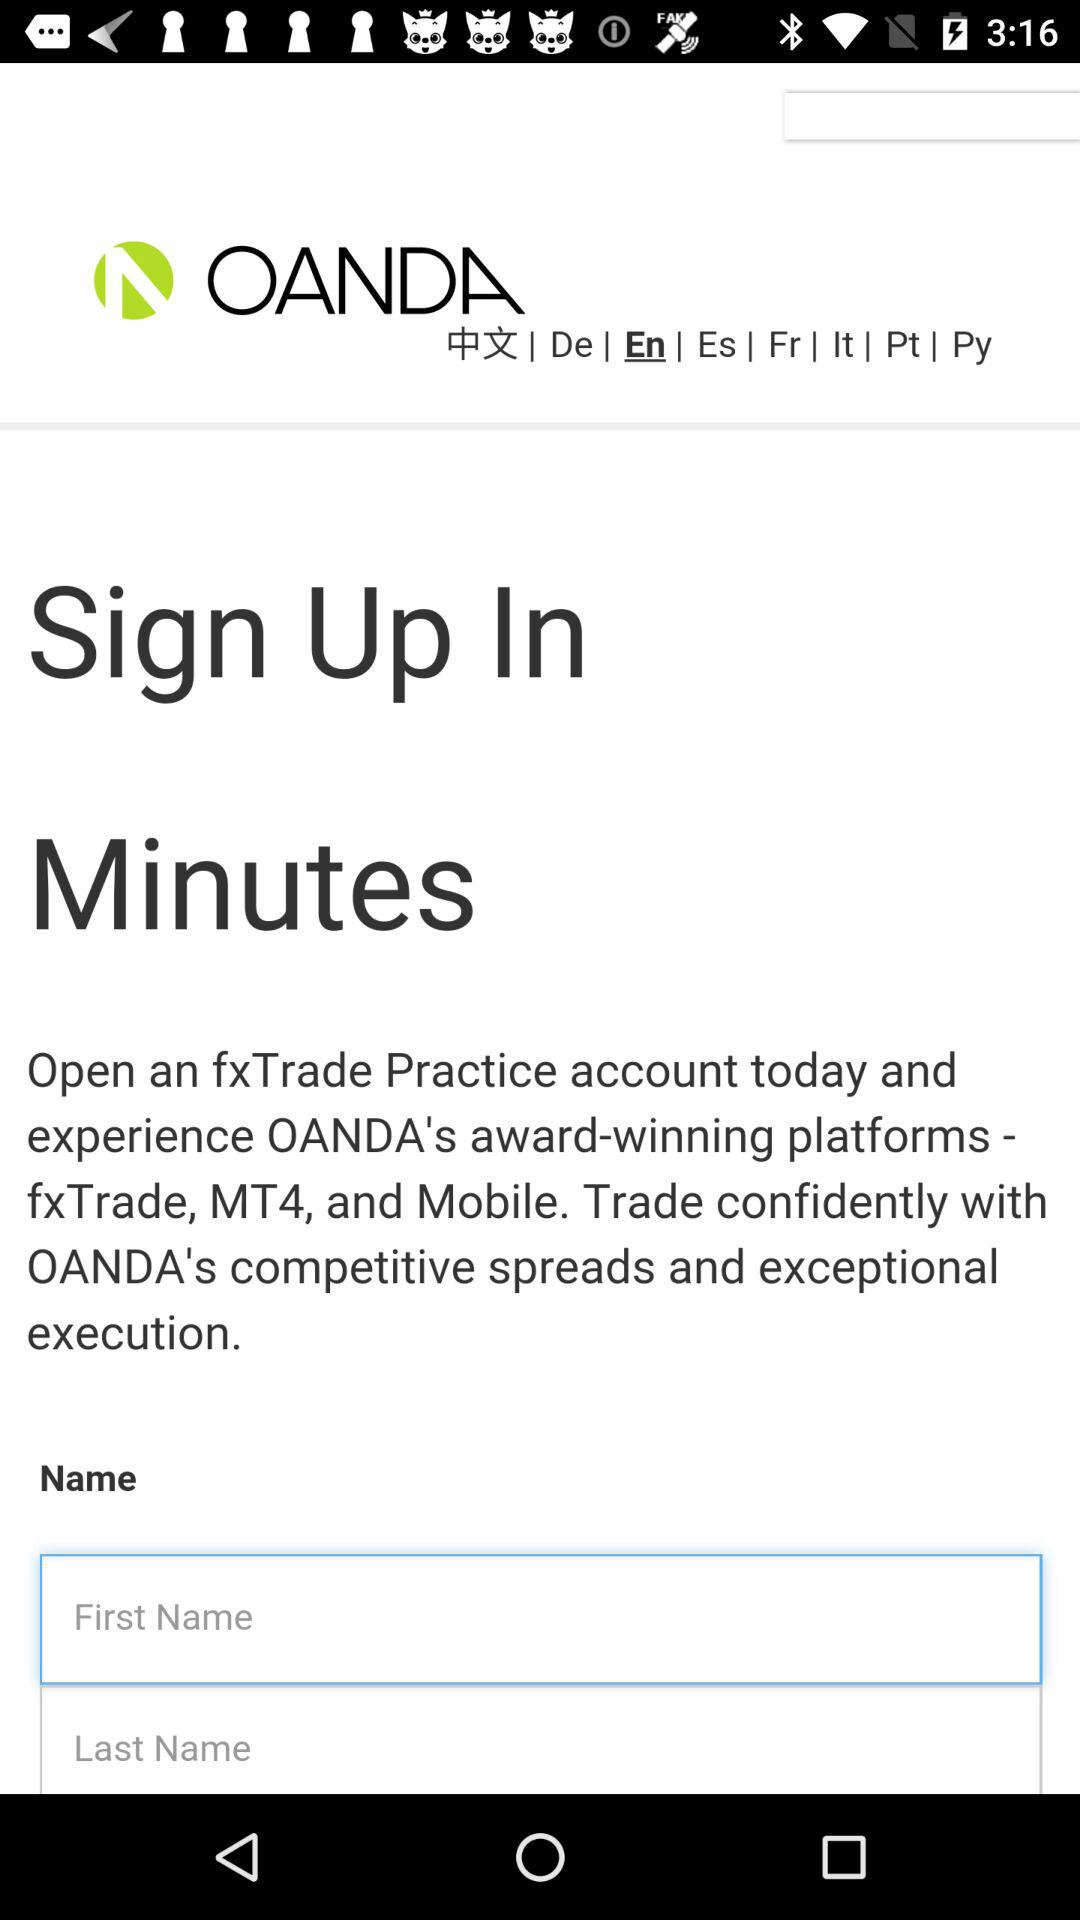What is the user's last name?
When the provided information is insufficient, respond with <no answer>. <no answer> 